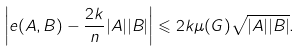Convert formula to latex. <formula><loc_0><loc_0><loc_500><loc_500>\left | e ( A , B ) - \frac { 2 k } { n } | A | | B | \right | \leqslant 2 k \mu ( G ) \sqrt { | A | | B | } .</formula> 